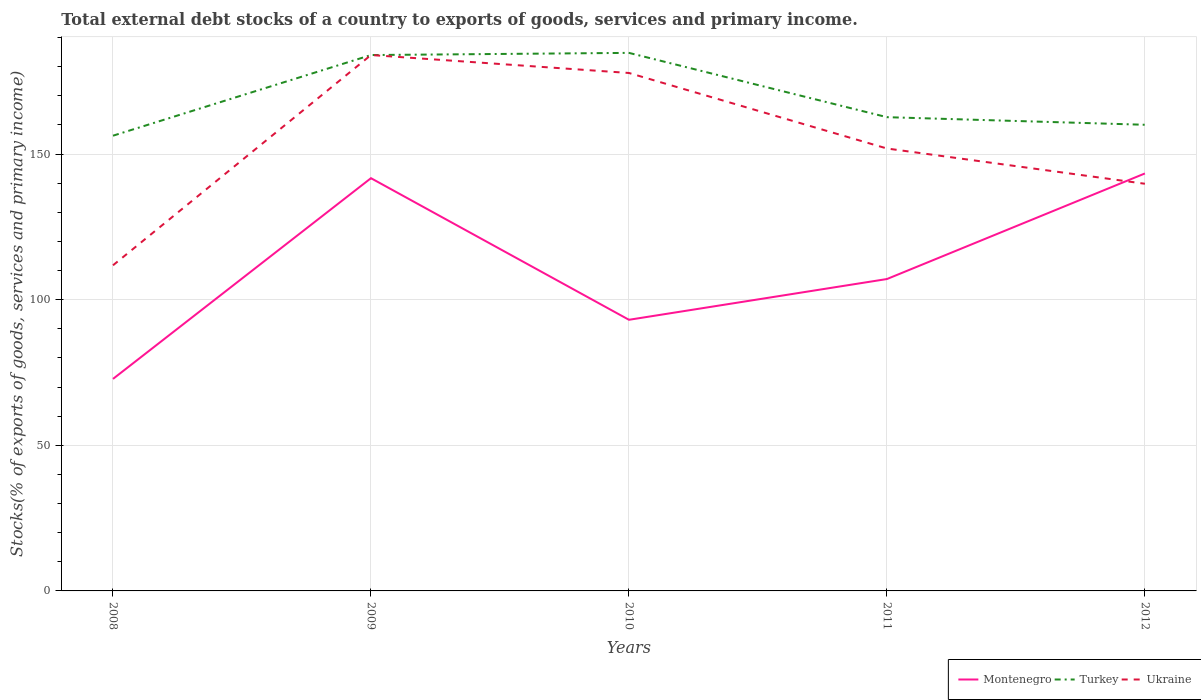Does the line corresponding to Ukraine intersect with the line corresponding to Turkey?
Give a very brief answer. Yes. Is the number of lines equal to the number of legend labels?
Offer a terse response. Yes. Across all years, what is the maximum total debt stocks in Montenegro?
Ensure brevity in your answer.  72.79. What is the total total debt stocks in Turkey in the graph?
Give a very brief answer. 21.33. What is the difference between the highest and the second highest total debt stocks in Turkey?
Provide a succinct answer. 28.43. What is the difference between the highest and the lowest total debt stocks in Turkey?
Keep it short and to the point. 2. How many lines are there?
Your answer should be very brief. 3. Does the graph contain grids?
Offer a very short reply. Yes. Where does the legend appear in the graph?
Your answer should be compact. Bottom right. What is the title of the graph?
Offer a terse response. Total external debt stocks of a country to exports of goods, services and primary income. Does "Bosnia and Herzegovina" appear as one of the legend labels in the graph?
Make the answer very short. No. What is the label or title of the Y-axis?
Keep it short and to the point. Stocks(% of exports of goods, services and primary income). What is the Stocks(% of exports of goods, services and primary income) of Montenegro in 2008?
Your answer should be very brief. 72.79. What is the Stocks(% of exports of goods, services and primary income) in Turkey in 2008?
Your answer should be very brief. 156.29. What is the Stocks(% of exports of goods, services and primary income) of Ukraine in 2008?
Offer a terse response. 111.79. What is the Stocks(% of exports of goods, services and primary income) in Montenegro in 2009?
Offer a very short reply. 141.71. What is the Stocks(% of exports of goods, services and primary income) of Turkey in 2009?
Offer a terse response. 183.98. What is the Stocks(% of exports of goods, services and primary income) of Ukraine in 2009?
Give a very brief answer. 183.99. What is the Stocks(% of exports of goods, services and primary income) in Montenegro in 2010?
Your answer should be very brief. 93.09. What is the Stocks(% of exports of goods, services and primary income) in Turkey in 2010?
Provide a succinct answer. 184.73. What is the Stocks(% of exports of goods, services and primary income) of Ukraine in 2010?
Your answer should be compact. 177.82. What is the Stocks(% of exports of goods, services and primary income) in Montenegro in 2011?
Your answer should be very brief. 107.08. What is the Stocks(% of exports of goods, services and primary income) of Turkey in 2011?
Provide a succinct answer. 162.65. What is the Stocks(% of exports of goods, services and primary income) in Ukraine in 2011?
Provide a succinct answer. 151.9. What is the Stocks(% of exports of goods, services and primary income) in Montenegro in 2012?
Your response must be concise. 143.33. What is the Stocks(% of exports of goods, services and primary income) in Turkey in 2012?
Your answer should be compact. 160.04. What is the Stocks(% of exports of goods, services and primary income) in Ukraine in 2012?
Give a very brief answer. 139.79. Across all years, what is the maximum Stocks(% of exports of goods, services and primary income) of Montenegro?
Your response must be concise. 143.33. Across all years, what is the maximum Stocks(% of exports of goods, services and primary income) of Turkey?
Offer a very short reply. 184.73. Across all years, what is the maximum Stocks(% of exports of goods, services and primary income) in Ukraine?
Offer a terse response. 183.99. Across all years, what is the minimum Stocks(% of exports of goods, services and primary income) in Montenegro?
Give a very brief answer. 72.79. Across all years, what is the minimum Stocks(% of exports of goods, services and primary income) of Turkey?
Offer a terse response. 156.29. Across all years, what is the minimum Stocks(% of exports of goods, services and primary income) in Ukraine?
Provide a short and direct response. 111.79. What is the total Stocks(% of exports of goods, services and primary income) in Montenegro in the graph?
Give a very brief answer. 557.99. What is the total Stocks(% of exports of goods, services and primary income) in Turkey in the graph?
Your response must be concise. 847.69. What is the total Stocks(% of exports of goods, services and primary income) in Ukraine in the graph?
Keep it short and to the point. 765.29. What is the difference between the Stocks(% of exports of goods, services and primary income) of Montenegro in 2008 and that in 2009?
Your response must be concise. -68.92. What is the difference between the Stocks(% of exports of goods, services and primary income) in Turkey in 2008 and that in 2009?
Provide a succinct answer. -27.69. What is the difference between the Stocks(% of exports of goods, services and primary income) in Ukraine in 2008 and that in 2009?
Your answer should be compact. -72.19. What is the difference between the Stocks(% of exports of goods, services and primary income) in Montenegro in 2008 and that in 2010?
Offer a terse response. -20.3. What is the difference between the Stocks(% of exports of goods, services and primary income) in Turkey in 2008 and that in 2010?
Keep it short and to the point. -28.43. What is the difference between the Stocks(% of exports of goods, services and primary income) of Ukraine in 2008 and that in 2010?
Ensure brevity in your answer.  -66.03. What is the difference between the Stocks(% of exports of goods, services and primary income) of Montenegro in 2008 and that in 2011?
Your answer should be very brief. -34.29. What is the difference between the Stocks(% of exports of goods, services and primary income) in Turkey in 2008 and that in 2011?
Provide a short and direct response. -6.36. What is the difference between the Stocks(% of exports of goods, services and primary income) of Ukraine in 2008 and that in 2011?
Provide a short and direct response. -40.1. What is the difference between the Stocks(% of exports of goods, services and primary income) in Montenegro in 2008 and that in 2012?
Make the answer very short. -70.54. What is the difference between the Stocks(% of exports of goods, services and primary income) in Turkey in 2008 and that in 2012?
Keep it short and to the point. -3.75. What is the difference between the Stocks(% of exports of goods, services and primary income) of Ukraine in 2008 and that in 2012?
Keep it short and to the point. -28. What is the difference between the Stocks(% of exports of goods, services and primary income) of Montenegro in 2009 and that in 2010?
Make the answer very short. 48.62. What is the difference between the Stocks(% of exports of goods, services and primary income) of Turkey in 2009 and that in 2010?
Your response must be concise. -0.74. What is the difference between the Stocks(% of exports of goods, services and primary income) in Ukraine in 2009 and that in 2010?
Provide a short and direct response. 6.16. What is the difference between the Stocks(% of exports of goods, services and primary income) of Montenegro in 2009 and that in 2011?
Your answer should be very brief. 34.63. What is the difference between the Stocks(% of exports of goods, services and primary income) in Turkey in 2009 and that in 2011?
Make the answer very short. 21.33. What is the difference between the Stocks(% of exports of goods, services and primary income) in Ukraine in 2009 and that in 2011?
Provide a succinct answer. 32.09. What is the difference between the Stocks(% of exports of goods, services and primary income) of Montenegro in 2009 and that in 2012?
Offer a terse response. -1.62. What is the difference between the Stocks(% of exports of goods, services and primary income) of Turkey in 2009 and that in 2012?
Provide a succinct answer. 23.94. What is the difference between the Stocks(% of exports of goods, services and primary income) in Ukraine in 2009 and that in 2012?
Provide a succinct answer. 44.19. What is the difference between the Stocks(% of exports of goods, services and primary income) of Montenegro in 2010 and that in 2011?
Make the answer very short. -13.99. What is the difference between the Stocks(% of exports of goods, services and primary income) of Turkey in 2010 and that in 2011?
Offer a terse response. 22.08. What is the difference between the Stocks(% of exports of goods, services and primary income) of Ukraine in 2010 and that in 2011?
Offer a very short reply. 25.93. What is the difference between the Stocks(% of exports of goods, services and primary income) in Montenegro in 2010 and that in 2012?
Offer a very short reply. -50.24. What is the difference between the Stocks(% of exports of goods, services and primary income) of Turkey in 2010 and that in 2012?
Make the answer very short. 24.69. What is the difference between the Stocks(% of exports of goods, services and primary income) of Ukraine in 2010 and that in 2012?
Offer a very short reply. 38.03. What is the difference between the Stocks(% of exports of goods, services and primary income) of Montenegro in 2011 and that in 2012?
Your answer should be compact. -36.25. What is the difference between the Stocks(% of exports of goods, services and primary income) in Turkey in 2011 and that in 2012?
Offer a terse response. 2.61. What is the difference between the Stocks(% of exports of goods, services and primary income) of Ukraine in 2011 and that in 2012?
Provide a succinct answer. 12.11. What is the difference between the Stocks(% of exports of goods, services and primary income) of Montenegro in 2008 and the Stocks(% of exports of goods, services and primary income) of Turkey in 2009?
Your answer should be compact. -111.19. What is the difference between the Stocks(% of exports of goods, services and primary income) of Montenegro in 2008 and the Stocks(% of exports of goods, services and primary income) of Ukraine in 2009?
Offer a terse response. -111.19. What is the difference between the Stocks(% of exports of goods, services and primary income) in Turkey in 2008 and the Stocks(% of exports of goods, services and primary income) in Ukraine in 2009?
Keep it short and to the point. -27.69. What is the difference between the Stocks(% of exports of goods, services and primary income) in Montenegro in 2008 and the Stocks(% of exports of goods, services and primary income) in Turkey in 2010?
Offer a terse response. -111.94. What is the difference between the Stocks(% of exports of goods, services and primary income) in Montenegro in 2008 and the Stocks(% of exports of goods, services and primary income) in Ukraine in 2010?
Provide a short and direct response. -105.03. What is the difference between the Stocks(% of exports of goods, services and primary income) in Turkey in 2008 and the Stocks(% of exports of goods, services and primary income) in Ukraine in 2010?
Give a very brief answer. -21.53. What is the difference between the Stocks(% of exports of goods, services and primary income) of Montenegro in 2008 and the Stocks(% of exports of goods, services and primary income) of Turkey in 2011?
Provide a short and direct response. -89.86. What is the difference between the Stocks(% of exports of goods, services and primary income) of Montenegro in 2008 and the Stocks(% of exports of goods, services and primary income) of Ukraine in 2011?
Your response must be concise. -79.11. What is the difference between the Stocks(% of exports of goods, services and primary income) in Turkey in 2008 and the Stocks(% of exports of goods, services and primary income) in Ukraine in 2011?
Your answer should be compact. 4.39. What is the difference between the Stocks(% of exports of goods, services and primary income) of Montenegro in 2008 and the Stocks(% of exports of goods, services and primary income) of Turkey in 2012?
Provide a short and direct response. -87.25. What is the difference between the Stocks(% of exports of goods, services and primary income) in Montenegro in 2008 and the Stocks(% of exports of goods, services and primary income) in Ukraine in 2012?
Your answer should be compact. -67. What is the difference between the Stocks(% of exports of goods, services and primary income) in Turkey in 2008 and the Stocks(% of exports of goods, services and primary income) in Ukraine in 2012?
Offer a terse response. 16.5. What is the difference between the Stocks(% of exports of goods, services and primary income) in Montenegro in 2009 and the Stocks(% of exports of goods, services and primary income) in Turkey in 2010?
Provide a succinct answer. -43.02. What is the difference between the Stocks(% of exports of goods, services and primary income) of Montenegro in 2009 and the Stocks(% of exports of goods, services and primary income) of Ukraine in 2010?
Keep it short and to the point. -36.12. What is the difference between the Stocks(% of exports of goods, services and primary income) of Turkey in 2009 and the Stocks(% of exports of goods, services and primary income) of Ukraine in 2010?
Your answer should be very brief. 6.16. What is the difference between the Stocks(% of exports of goods, services and primary income) in Montenegro in 2009 and the Stocks(% of exports of goods, services and primary income) in Turkey in 2011?
Provide a succinct answer. -20.94. What is the difference between the Stocks(% of exports of goods, services and primary income) of Montenegro in 2009 and the Stocks(% of exports of goods, services and primary income) of Ukraine in 2011?
Provide a succinct answer. -10.19. What is the difference between the Stocks(% of exports of goods, services and primary income) in Turkey in 2009 and the Stocks(% of exports of goods, services and primary income) in Ukraine in 2011?
Provide a short and direct response. 32.08. What is the difference between the Stocks(% of exports of goods, services and primary income) of Montenegro in 2009 and the Stocks(% of exports of goods, services and primary income) of Turkey in 2012?
Offer a terse response. -18.33. What is the difference between the Stocks(% of exports of goods, services and primary income) in Montenegro in 2009 and the Stocks(% of exports of goods, services and primary income) in Ukraine in 2012?
Keep it short and to the point. 1.91. What is the difference between the Stocks(% of exports of goods, services and primary income) of Turkey in 2009 and the Stocks(% of exports of goods, services and primary income) of Ukraine in 2012?
Provide a succinct answer. 44.19. What is the difference between the Stocks(% of exports of goods, services and primary income) in Montenegro in 2010 and the Stocks(% of exports of goods, services and primary income) in Turkey in 2011?
Keep it short and to the point. -69.56. What is the difference between the Stocks(% of exports of goods, services and primary income) of Montenegro in 2010 and the Stocks(% of exports of goods, services and primary income) of Ukraine in 2011?
Your answer should be compact. -58.81. What is the difference between the Stocks(% of exports of goods, services and primary income) in Turkey in 2010 and the Stocks(% of exports of goods, services and primary income) in Ukraine in 2011?
Your answer should be very brief. 32.83. What is the difference between the Stocks(% of exports of goods, services and primary income) in Montenegro in 2010 and the Stocks(% of exports of goods, services and primary income) in Turkey in 2012?
Provide a succinct answer. -66.95. What is the difference between the Stocks(% of exports of goods, services and primary income) in Montenegro in 2010 and the Stocks(% of exports of goods, services and primary income) in Ukraine in 2012?
Give a very brief answer. -46.7. What is the difference between the Stocks(% of exports of goods, services and primary income) in Turkey in 2010 and the Stocks(% of exports of goods, services and primary income) in Ukraine in 2012?
Provide a succinct answer. 44.93. What is the difference between the Stocks(% of exports of goods, services and primary income) in Montenegro in 2011 and the Stocks(% of exports of goods, services and primary income) in Turkey in 2012?
Make the answer very short. -52.96. What is the difference between the Stocks(% of exports of goods, services and primary income) of Montenegro in 2011 and the Stocks(% of exports of goods, services and primary income) of Ukraine in 2012?
Your answer should be compact. -32.71. What is the difference between the Stocks(% of exports of goods, services and primary income) of Turkey in 2011 and the Stocks(% of exports of goods, services and primary income) of Ukraine in 2012?
Give a very brief answer. 22.86. What is the average Stocks(% of exports of goods, services and primary income) in Montenegro per year?
Provide a succinct answer. 111.6. What is the average Stocks(% of exports of goods, services and primary income) in Turkey per year?
Your response must be concise. 169.54. What is the average Stocks(% of exports of goods, services and primary income) of Ukraine per year?
Provide a short and direct response. 153.06. In the year 2008, what is the difference between the Stocks(% of exports of goods, services and primary income) of Montenegro and Stocks(% of exports of goods, services and primary income) of Turkey?
Provide a short and direct response. -83.5. In the year 2008, what is the difference between the Stocks(% of exports of goods, services and primary income) of Montenegro and Stocks(% of exports of goods, services and primary income) of Ukraine?
Give a very brief answer. -39. In the year 2008, what is the difference between the Stocks(% of exports of goods, services and primary income) in Turkey and Stocks(% of exports of goods, services and primary income) in Ukraine?
Your answer should be compact. 44.5. In the year 2009, what is the difference between the Stocks(% of exports of goods, services and primary income) in Montenegro and Stocks(% of exports of goods, services and primary income) in Turkey?
Provide a short and direct response. -42.28. In the year 2009, what is the difference between the Stocks(% of exports of goods, services and primary income) in Montenegro and Stocks(% of exports of goods, services and primary income) in Ukraine?
Your answer should be very brief. -42.28. In the year 2009, what is the difference between the Stocks(% of exports of goods, services and primary income) of Turkey and Stocks(% of exports of goods, services and primary income) of Ukraine?
Make the answer very short. -0. In the year 2010, what is the difference between the Stocks(% of exports of goods, services and primary income) of Montenegro and Stocks(% of exports of goods, services and primary income) of Turkey?
Your answer should be very brief. -91.64. In the year 2010, what is the difference between the Stocks(% of exports of goods, services and primary income) of Montenegro and Stocks(% of exports of goods, services and primary income) of Ukraine?
Provide a short and direct response. -84.74. In the year 2010, what is the difference between the Stocks(% of exports of goods, services and primary income) of Turkey and Stocks(% of exports of goods, services and primary income) of Ukraine?
Offer a very short reply. 6.9. In the year 2011, what is the difference between the Stocks(% of exports of goods, services and primary income) in Montenegro and Stocks(% of exports of goods, services and primary income) in Turkey?
Give a very brief answer. -55.57. In the year 2011, what is the difference between the Stocks(% of exports of goods, services and primary income) in Montenegro and Stocks(% of exports of goods, services and primary income) in Ukraine?
Ensure brevity in your answer.  -44.82. In the year 2011, what is the difference between the Stocks(% of exports of goods, services and primary income) of Turkey and Stocks(% of exports of goods, services and primary income) of Ukraine?
Keep it short and to the point. 10.75. In the year 2012, what is the difference between the Stocks(% of exports of goods, services and primary income) in Montenegro and Stocks(% of exports of goods, services and primary income) in Turkey?
Provide a succinct answer. -16.71. In the year 2012, what is the difference between the Stocks(% of exports of goods, services and primary income) in Montenegro and Stocks(% of exports of goods, services and primary income) in Ukraine?
Make the answer very short. 3.54. In the year 2012, what is the difference between the Stocks(% of exports of goods, services and primary income) in Turkey and Stocks(% of exports of goods, services and primary income) in Ukraine?
Give a very brief answer. 20.25. What is the ratio of the Stocks(% of exports of goods, services and primary income) of Montenegro in 2008 to that in 2009?
Make the answer very short. 0.51. What is the ratio of the Stocks(% of exports of goods, services and primary income) of Turkey in 2008 to that in 2009?
Give a very brief answer. 0.85. What is the ratio of the Stocks(% of exports of goods, services and primary income) of Ukraine in 2008 to that in 2009?
Offer a very short reply. 0.61. What is the ratio of the Stocks(% of exports of goods, services and primary income) in Montenegro in 2008 to that in 2010?
Provide a short and direct response. 0.78. What is the ratio of the Stocks(% of exports of goods, services and primary income) of Turkey in 2008 to that in 2010?
Your response must be concise. 0.85. What is the ratio of the Stocks(% of exports of goods, services and primary income) of Ukraine in 2008 to that in 2010?
Ensure brevity in your answer.  0.63. What is the ratio of the Stocks(% of exports of goods, services and primary income) of Montenegro in 2008 to that in 2011?
Provide a succinct answer. 0.68. What is the ratio of the Stocks(% of exports of goods, services and primary income) of Turkey in 2008 to that in 2011?
Provide a short and direct response. 0.96. What is the ratio of the Stocks(% of exports of goods, services and primary income) in Ukraine in 2008 to that in 2011?
Your answer should be very brief. 0.74. What is the ratio of the Stocks(% of exports of goods, services and primary income) in Montenegro in 2008 to that in 2012?
Provide a short and direct response. 0.51. What is the ratio of the Stocks(% of exports of goods, services and primary income) in Turkey in 2008 to that in 2012?
Ensure brevity in your answer.  0.98. What is the ratio of the Stocks(% of exports of goods, services and primary income) of Ukraine in 2008 to that in 2012?
Keep it short and to the point. 0.8. What is the ratio of the Stocks(% of exports of goods, services and primary income) in Montenegro in 2009 to that in 2010?
Your response must be concise. 1.52. What is the ratio of the Stocks(% of exports of goods, services and primary income) of Ukraine in 2009 to that in 2010?
Your answer should be compact. 1.03. What is the ratio of the Stocks(% of exports of goods, services and primary income) in Montenegro in 2009 to that in 2011?
Make the answer very short. 1.32. What is the ratio of the Stocks(% of exports of goods, services and primary income) in Turkey in 2009 to that in 2011?
Ensure brevity in your answer.  1.13. What is the ratio of the Stocks(% of exports of goods, services and primary income) of Ukraine in 2009 to that in 2011?
Your response must be concise. 1.21. What is the ratio of the Stocks(% of exports of goods, services and primary income) of Montenegro in 2009 to that in 2012?
Provide a short and direct response. 0.99. What is the ratio of the Stocks(% of exports of goods, services and primary income) in Turkey in 2009 to that in 2012?
Offer a very short reply. 1.15. What is the ratio of the Stocks(% of exports of goods, services and primary income) in Ukraine in 2009 to that in 2012?
Your answer should be compact. 1.32. What is the ratio of the Stocks(% of exports of goods, services and primary income) of Montenegro in 2010 to that in 2011?
Ensure brevity in your answer.  0.87. What is the ratio of the Stocks(% of exports of goods, services and primary income) of Turkey in 2010 to that in 2011?
Make the answer very short. 1.14. What is the ratio of the Stocks(% of exports of goods, services and primary income) in Ukraine in 2010 to that in 2011?
Offer a very short reply. 1.17. What is the ratio of the Stocks(% of exports of goods, services and primary income) in Montenegro in 2010 to that in 2012?
Provide a short and direct response. 0.65. What is the ratio of the Stocks(% of exports of goods, services and primary income) of Turkey in 2010 to that in 2012?
Your answer should be compact. 1.15. What is the ratio of the Stocks(% of exports of goods, services and primary income) in Ukraine in 2010 to that in 2012?
Offer a terse response. 1.27. What is the ratio of the Stocks(% of exports of goods, services and primary income) in Montenegro in 2011 to that in 2012?
Make the answer very short. 0.75. What is the ratio of the Stocks(% of exports of goods, services and primary income) of Turkey in 2011 to that in 2012?
Give a very brief answer. 1.02. What is the ratio of the Stocks(% of exports of goods, services and primary income) in Ukraine in 2011 to that in 2012?
Make the answer very short. 1.09. What is the difference between the highest and the second highest Stocks(% of exports of goods, services and primary income) of Montenegro?
Your answer should be compact. 1.62. What is the difference between the highest and the second highest Stocks(% of exports of goods, services and primary income) in Turkey?
Offer a very short reply. 0.74. What is the difference between the highest and the second highest Stocks(% of exports of goods, services and primary income) in Ukraine?
Ensure brevity in your answer.  6.16. What is the difference between the highest and the lowest Stocks(% of exports of goods, services and primary income) of Montenegro?
Make the answer very short. 70.54. What is the difference between the highest and the lowest Stocks(% of exports of goods, services and primary income) of Turkey?
Your response must be concise. 28.43. What is the difference between the highest and the lowest Stocks(% of exports of goods, services and primary income) in Ukraine?
Your answer should be compact. 72.19. 